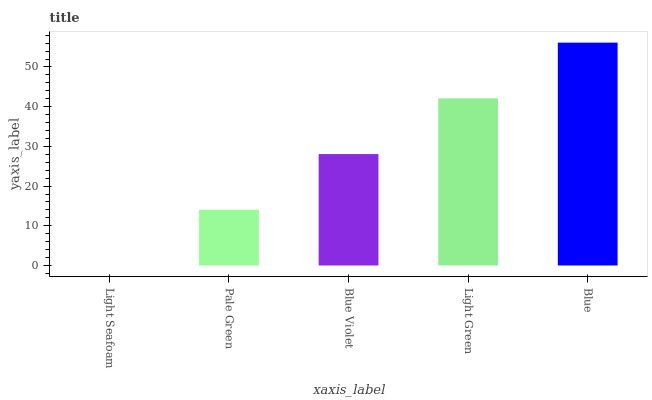Is Light Seafoam the minimum?
Answer yes or no. Yes. Is Blue the maximum?
Answer yes or no. Yes. Is Pale Green the minimum?
Answer yes or no. No. Is Pale Green the maximum?
Answer yes or no. No. Is Pale Green greater than Light Seafoam?
Answer yes or no. Yes. Is Light Seafoam less than Pale Green?
Answer yes or no. Yes. Is Light Seafoam greater than Pale Green?
Answer yes or no. No. Is Pale Green less than Light Seafoam?
Answer yes or no. No. Is Blue Violet the high median?
Answer yes or no. Yes. Is Blue Violet the low median?
Answer yes or no. Yes. Is Light Seafoam the high median?
Answer yes or no. No. Is Blue the low median?
Answer yes or no. No. 